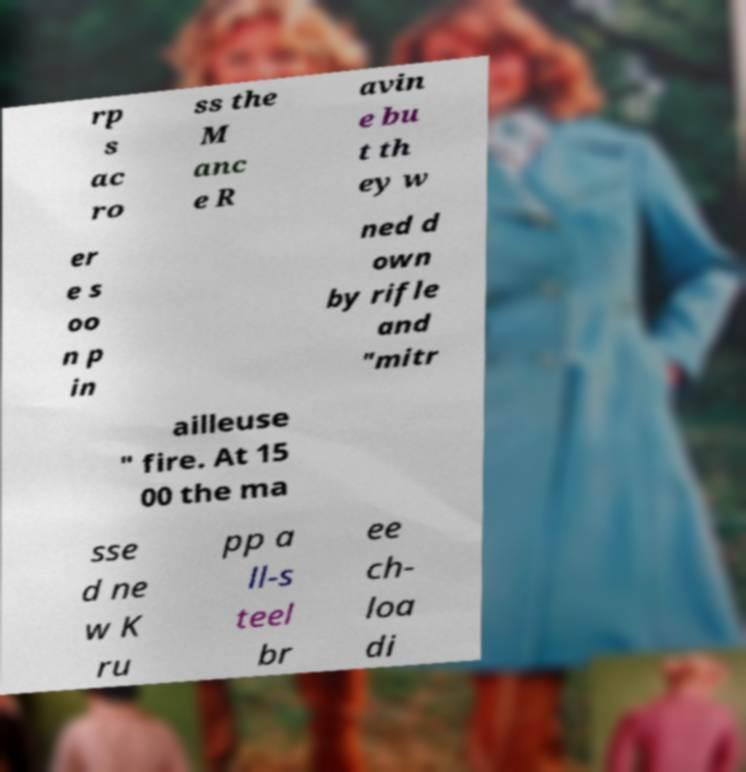Can you read and provide the text displayed in the image?This photo seems to have some interesting text. Can you extract and type it out for me? rp s ac ro ss the M anc e R avin e bu t th ey w er e s oo n p in ned d own by rifle and "mitr ailleuse " fire. At 15 00 the ma sse d ne w K ru pp a ll-s teel br ee ch- loa di 